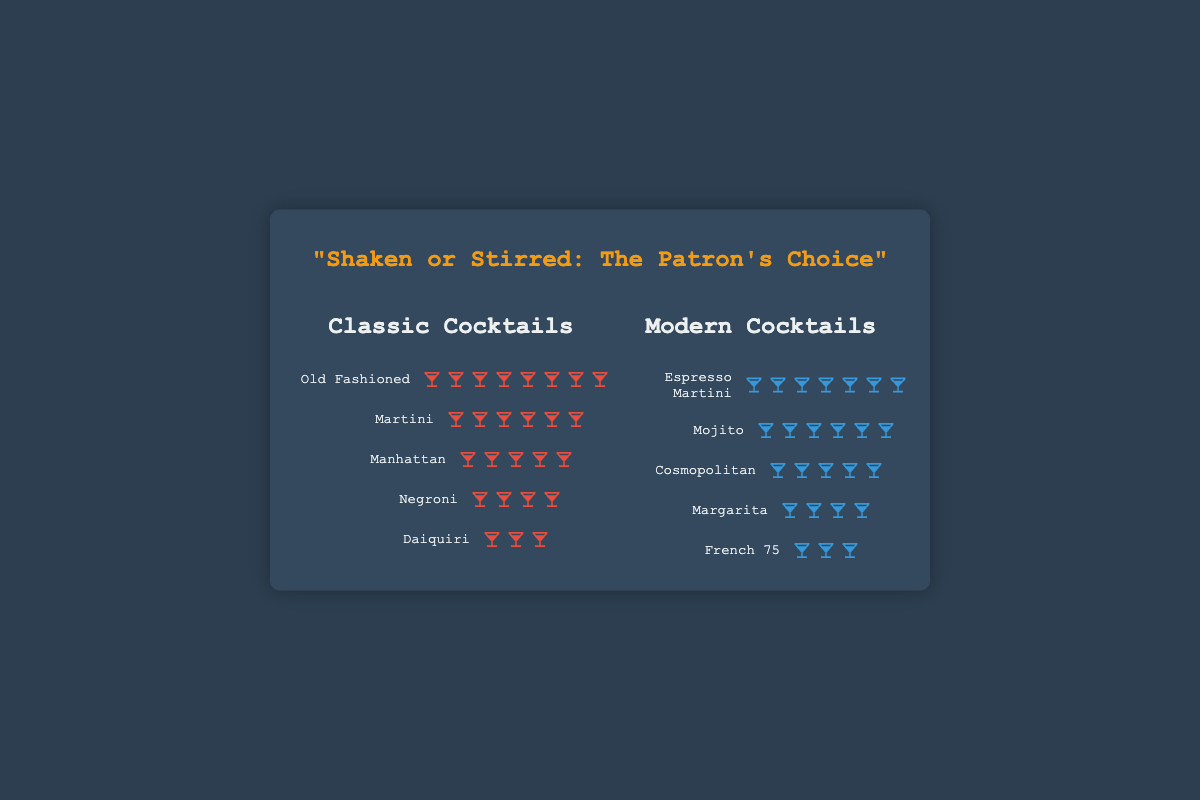How many patrons prefer the Martini cocktail? To find out how many patrons prefer the Martini cocktail, look in the column for Classic Cocktails. Locate the row labeled "Martini" and count the number of icons present.
Answer: 6 Which type of cocktail, classic or modern, has a higher patron count for its top-preferred drink? Identify the top-preferred drink in each column and compare their patron counts. The Old Fashioned in the Classic Cocktails column has 8 patrons, while Espresso Martini in the Modern Cocktails column has 7 patrons.
Answer: Classic What is the total number of patrons who prefer modern cocktails? Sum the patron counts for all cocktails in the Modern Cocktails column by counting the icons for each drink: Espresso Martini (7), Mojito (6), Cosmopolitan (5), Margarita (4), French 75 (3). Total is 7 + 6 + 5 + 4 + 3.
Answer: 25 Compare the Negroni and Margarita cocktails in terms of patron preference. Which one is favored more? Count the number of icons for both the Negroni in the Classic Cocktails column and the Margarita in the Modern Cocktails column. Negroni has 4 icons and Margarita also has 4 icons.
Answer: Equal How many modern cocktails have patron counts of 5 or more? Count the number of rows in the Modern Cocktails column where the number of icons is 5 or more: Espresso Martini (7), Mojito (6), and Cosmopolitan (5).
Answer: 3 What is the difference in patron counts between the most and least preferred cocktails in the Classic Cocktails column? Identify the most preferred (Old Fashioned with 8 patrons) and least preferred (Daiquiri with 3 patrons) cocktails in the Classic Cocktails column, then subtract the counts: 8 - 3.
Answer: 5 Which classic cocktail has a patron count closest to the number of patrons for the Cosmopolitan? Check the patron counts for each cocktail in the Classic Cocktails column and find the one closest to 5 (the patron count for Cosmopolitan). Both Manhattan and Negroni have counts close to 5, but Manhattan has exactly 5.
Answer: Manhattan If you combined the patrons of the Manhattan and Negroni cocktails, how many would there be? Add the patron counts for the Manhattan and Negroni from the Classic Cocktails column. Manhattan has 5 patrons and Negroni has 4 patrons.
Answer: 9 Which cocktail has the lowest patron count overall? Compare the patron counts of all the cocktails in both columns (Classic and Modern) and find the one with the fewest icons. French 75 and Daiquiri both have 3 patrons, but they have equal counts.
Answer: Daiquiri and French 75 